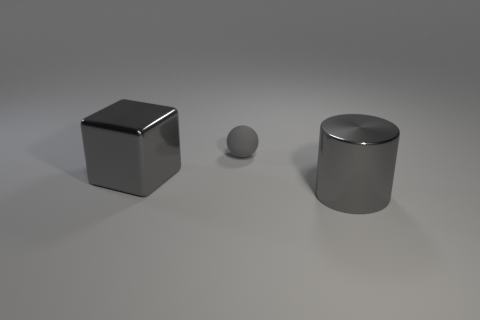What number of other things are the same size as the metallic cylinder? The metallic sphere is the only object that approximates the size of the metallic cylinder; it appears to be slightly smaller but within a comparable size range, thus making the count one. 